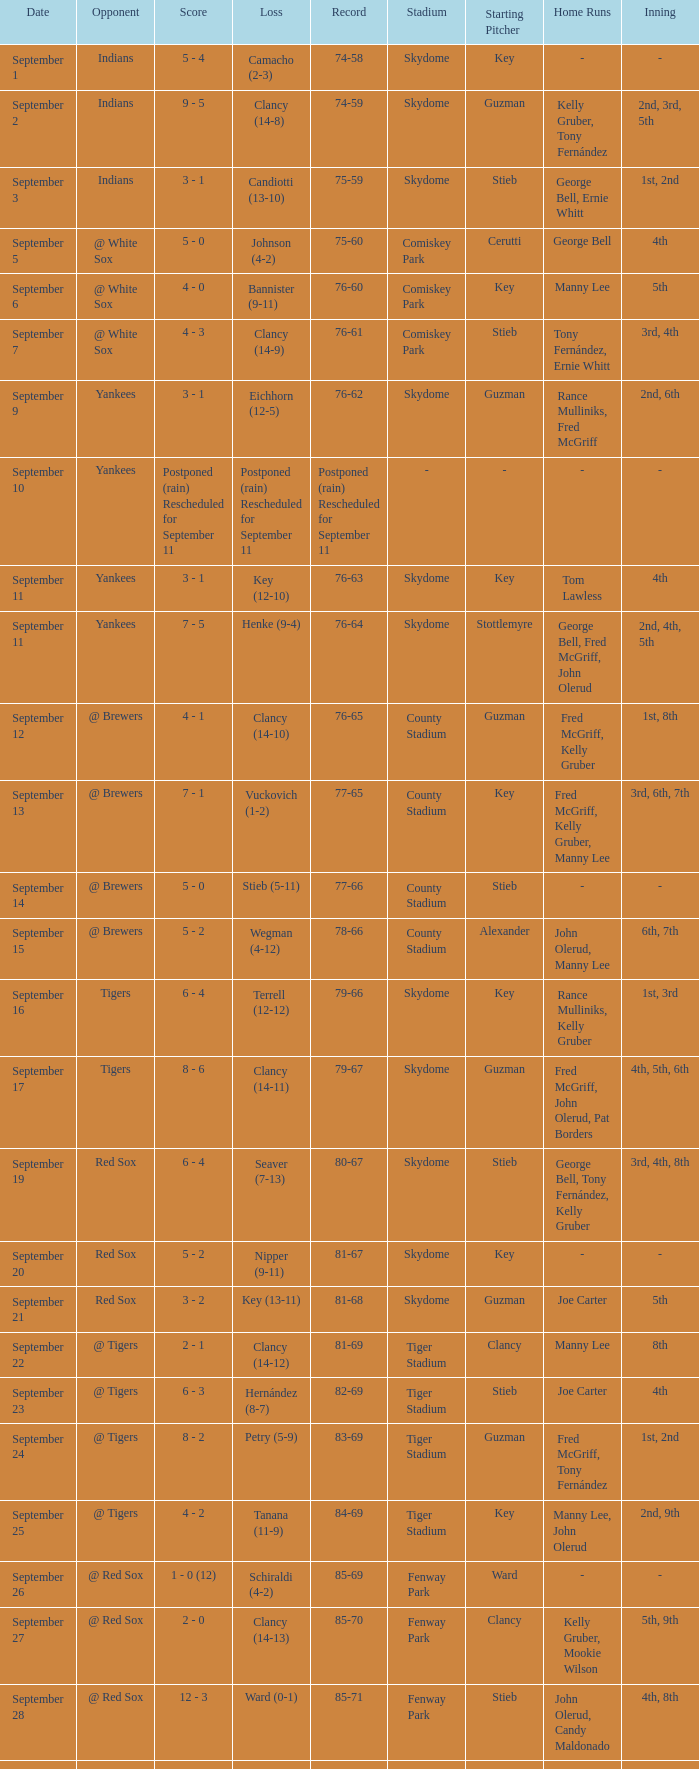What was the date of the game when their record was 84-69? September 25. 